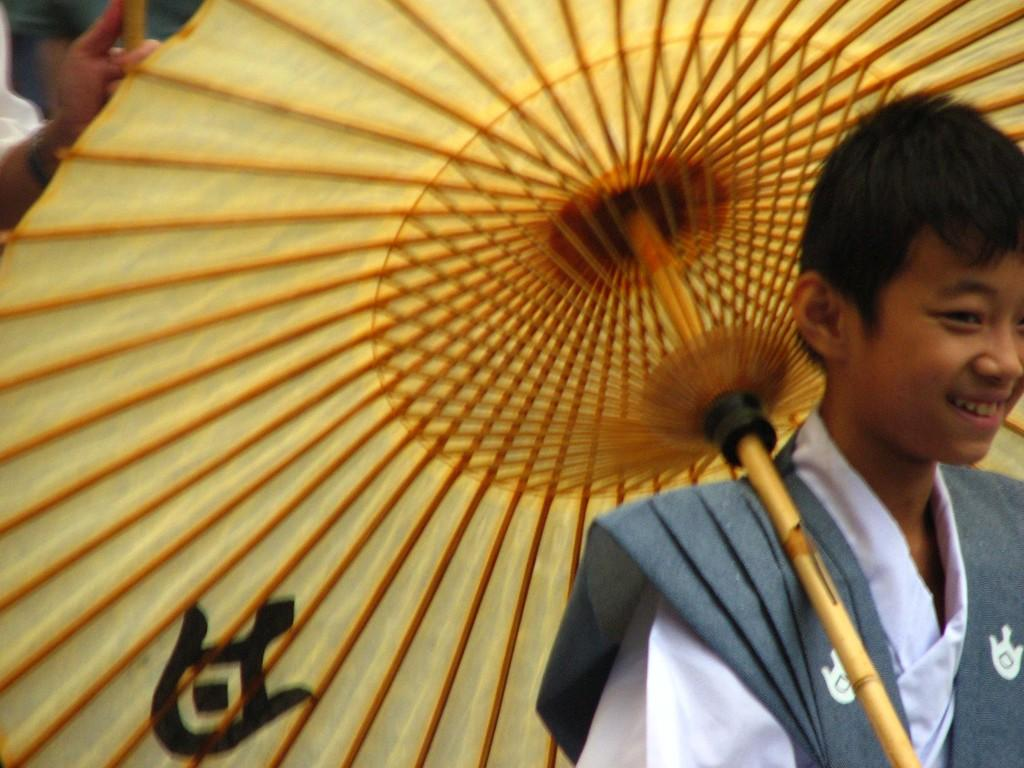What is the person on the right side of the image holding? The person on the right side of the image is holding an umbrella. Can you describe the people visible in the top left corner of the image? Unfortunately, the provided facts do not give any information about the people in the top left corner of the image. What is the weight of the person holding the umbrella in the image? The weight of the person holding the umbrella cannot be determined from the image. 